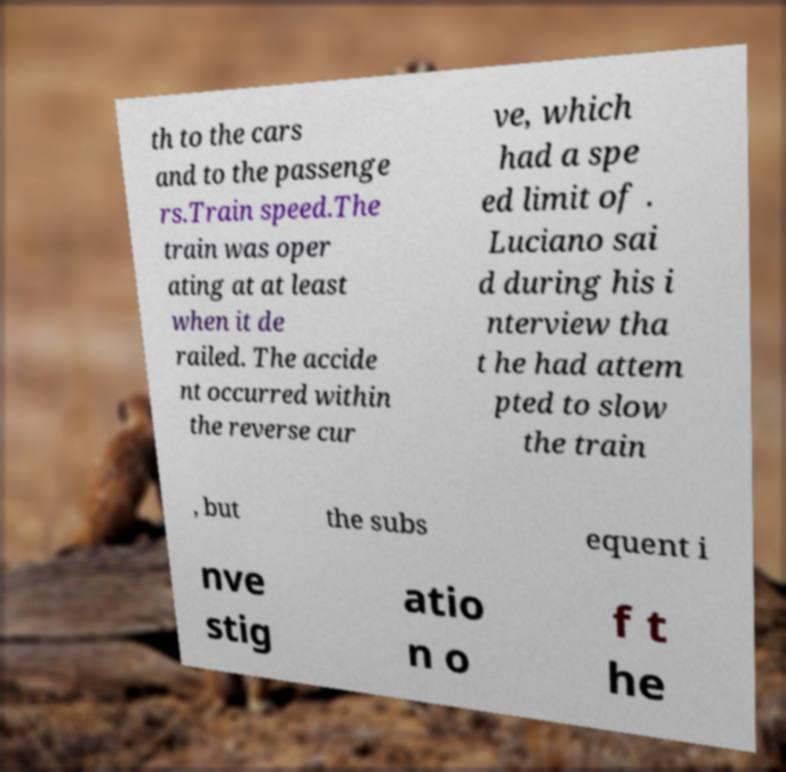Could you extract and type out the text from this image? th to the cars and to the passenge rs.Train speed.The train was oper ating at at least when it de railed. The accide nt occurred within the reverse cur ve, which had a spe ed limit of . Luciano sai d during his i nterview tha t he had attem pted to slow the train , but the subs equent i nve stig atio n o f t he 